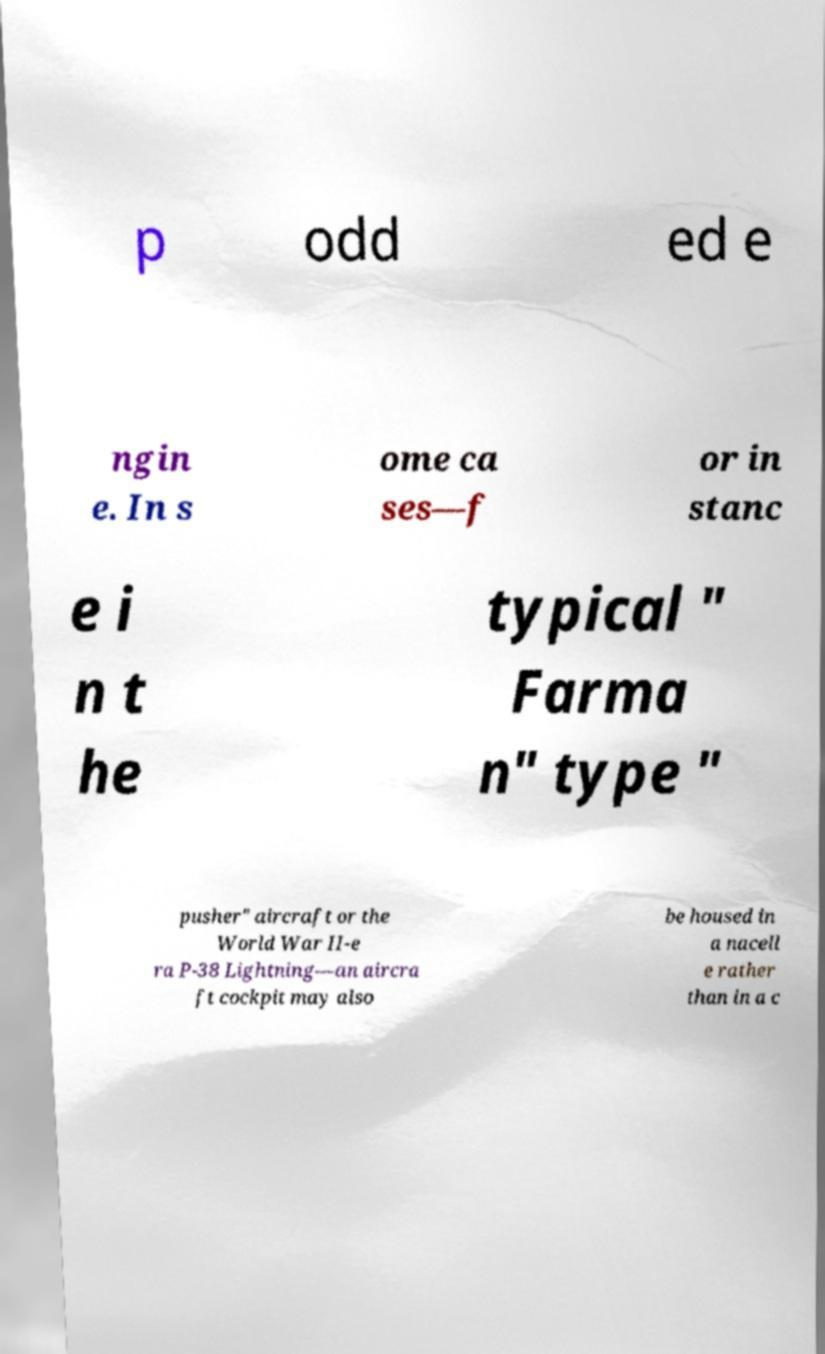Can you accurately transcribe the text from the provided image for me? p odd ed e ngin e. In s ome ca ses—f or in stanc e i n t he typical " Farma n" type " pusher" aircraft or the World War II-e ra P-38 Lightning—an aircra ft cockpit may also be housed in a nacell e rather than in a c 